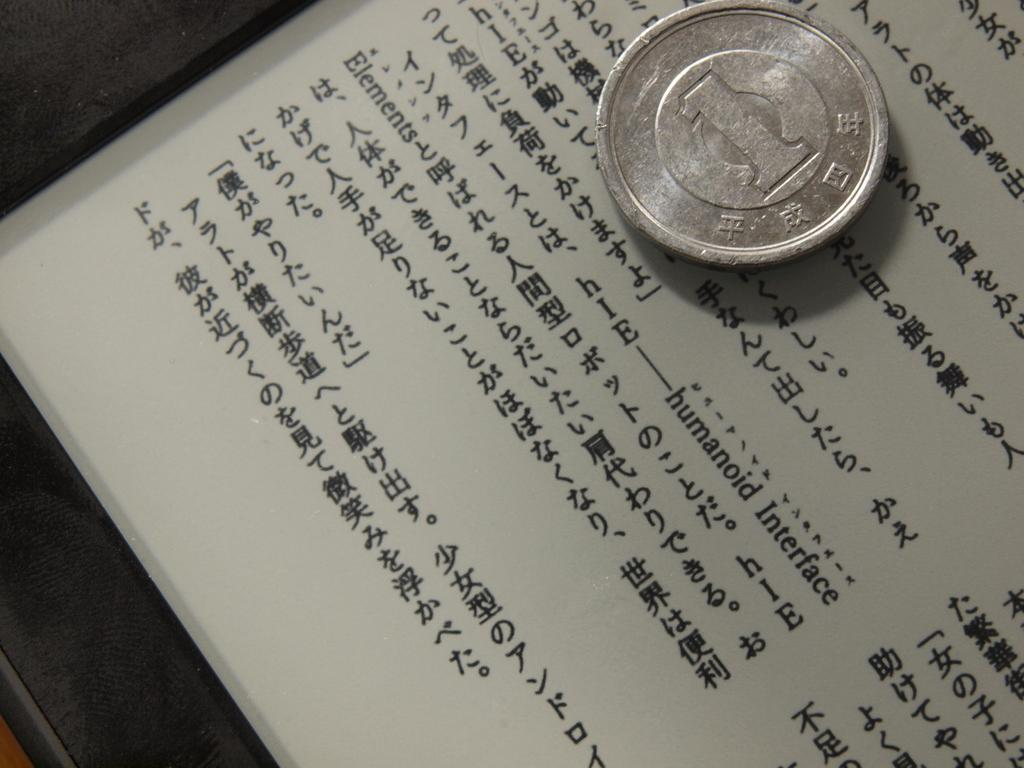Provide a one-sentence caption for the provided image. A silver coin with a numeral one on it sitting on top of a paper with asian writing. 